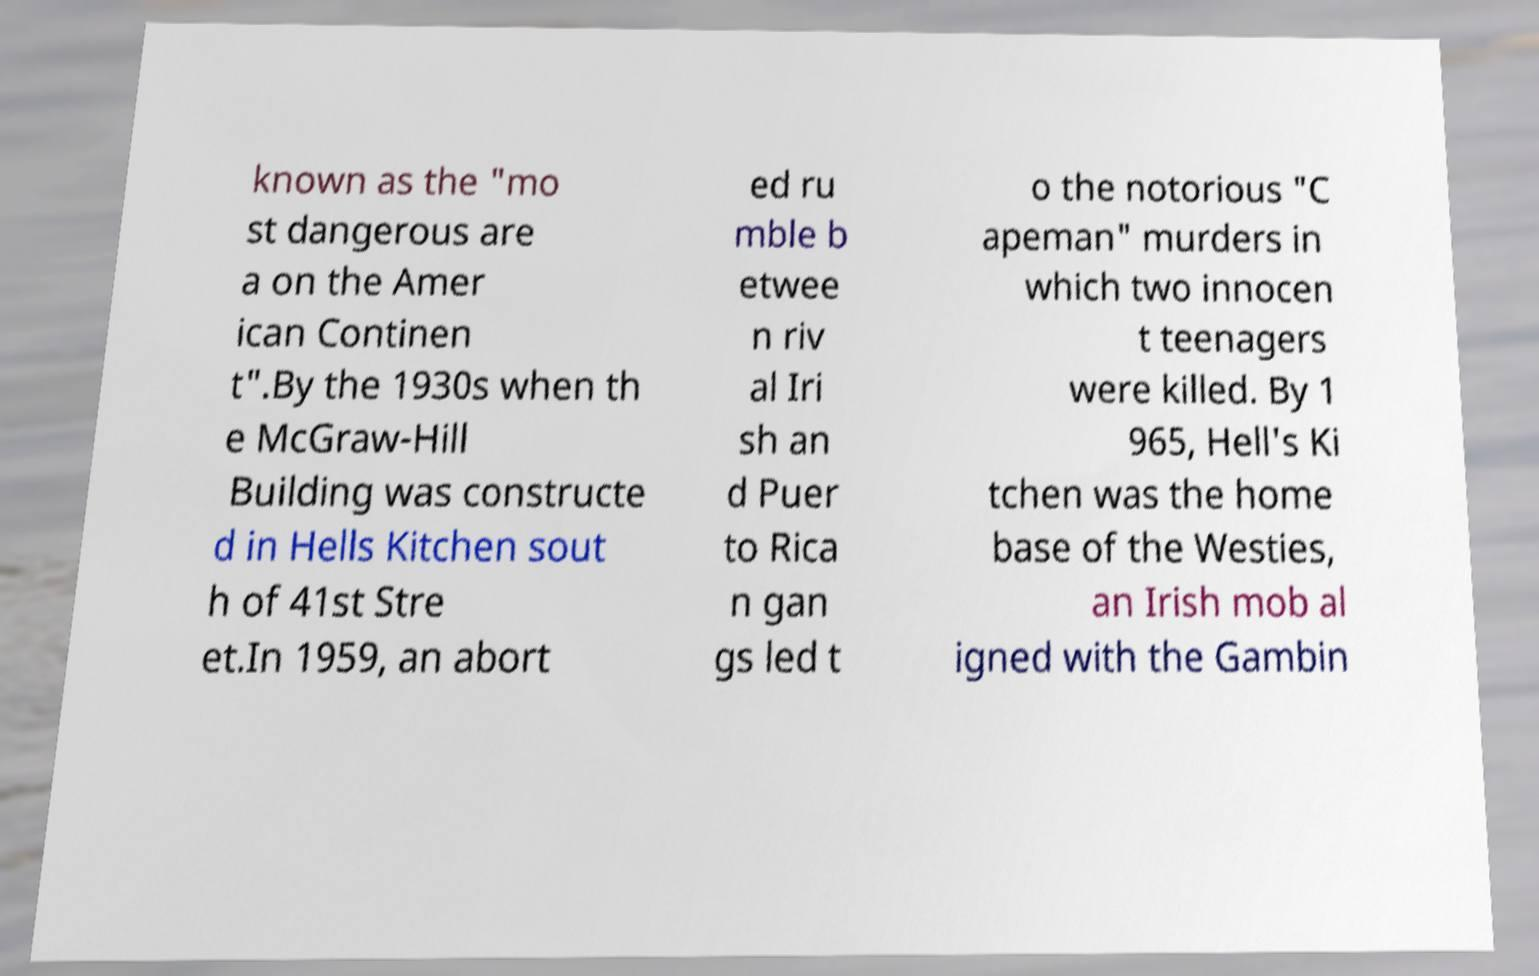Could you assist in decoding the text presented in this image and type it out clearly? known as the "mo st dangerous are a on the Amer ican Continen t".By the 1930s when th e McGraw-Hill Building was constructe d in Hells Kitchen sout h of 41st Stre et.In 1959, an abort ed ru mble b etwee n riv al Iri sh an d Puer to Rica n gan gs led t o the notorious "C apeman" murders in which two innocen t teenagers were killed. By 1 965, Hell's Ki tchen was the home base of the Westies, an Irish mob al igned with the Gambin 